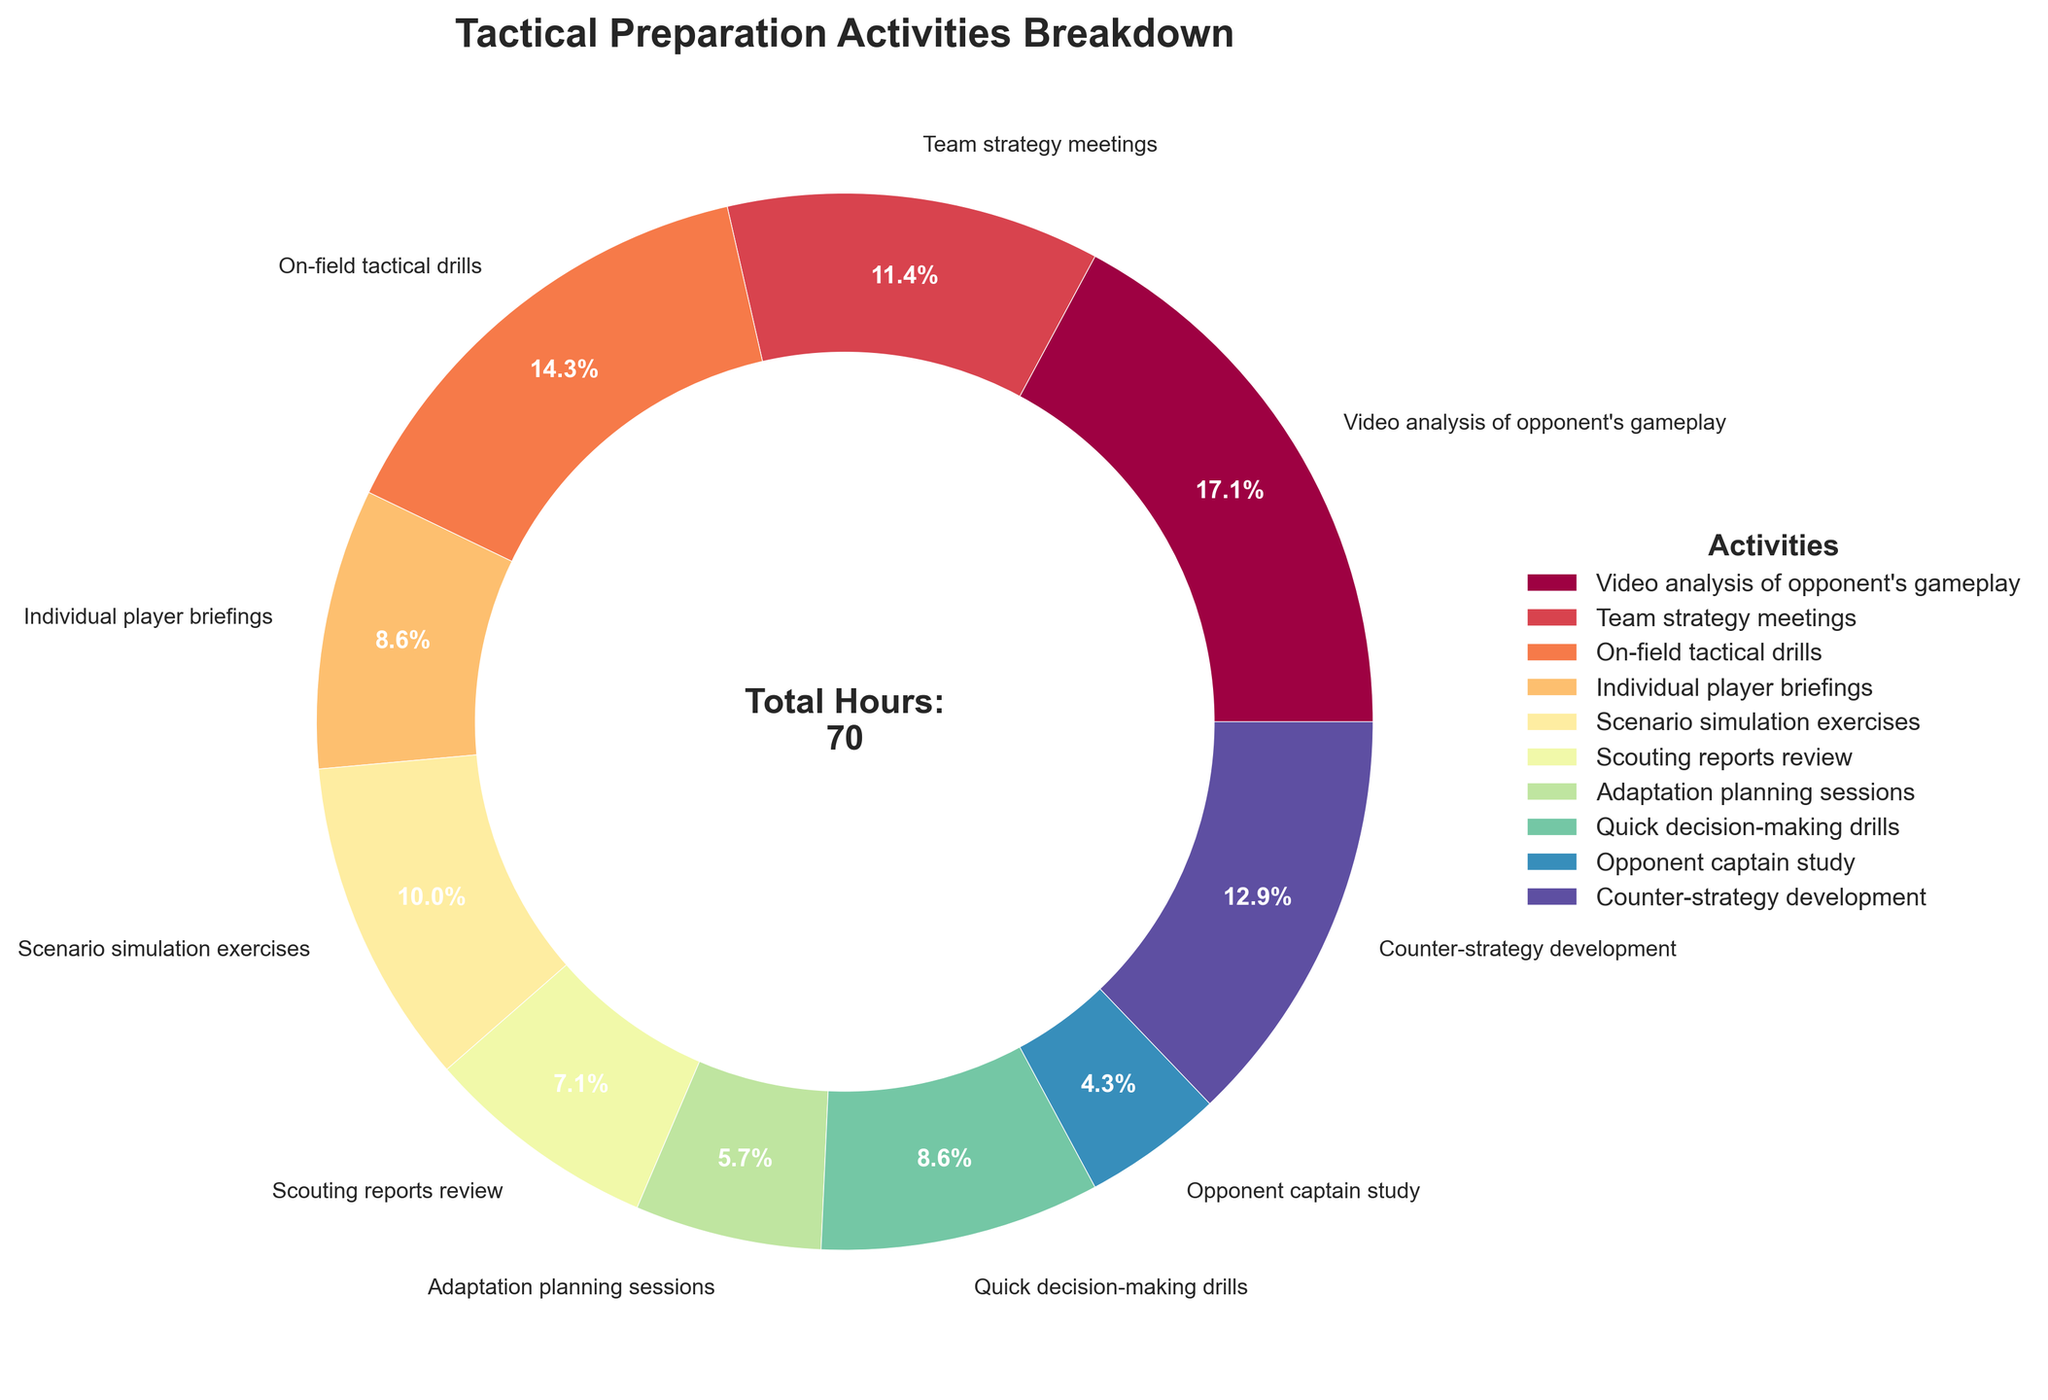What percentage of time is spent on Video analysis of opponent's gameplay? Video analysis of opponent's gameplay accounts for 12 hours. To find the percentage, divide 12 by the total hours and multiply by 100. Total hours = 70. (12 / 70) * 100 = 17.1%
Answer: 17.1% How many more hours are spent on On-field tactical drills compared to Opponent captain study? On-field tactical drills take 10 hours and Opponent captain study takes 3 hours. The difference is 10 - 3 = 7 hours
Answer: 7 hours Which activity takes up the second most amount of time? Counter-strategy development comes in second with 9 hours
Answer: Counter-strategy development How much time is spent on quick decision-making drills compared to Individual player briefings and Adaptation planning sessions combined? Quick decision-making drills: 6 hours. Individual player briefings: 6 hours. Adaptation planning sessions: 4 hours. Combined hours for the latter two = 6 + 4 = 10 hours. The comparison is 6 vs. 10 hours
Answer: 6 vs. 10 hours Which activity has the highest allocation of time and what is its percentage? The activity with the highest time allocation is Video analysis of opponent's gameplay with 12 hours. Percentage = (12 / 70) * 100 = 17.1%
Answer: Video analysis of opponent's gameplay, 17.1% What is the combined percentage of activities that take up less than 6 hours? Activities less than 6 hours: Scouting reports review (5 hours), Adaptation planning sessions (4 hours), and Opponent captain study (3 hours). Total hours = 5 + 4 + 3 = 12. Percentage = (12 / 70) * 100 = 17.1%
Answer: 17.1% Which activity occupies the smallest slice in the pie chart and what color is it? Opponent captain study is the smallest slice with 3 hours and it is represented in a color near the end of the color spectrum, likely a shade of purple.
Answer: Opponent captain study, purple What is the total number of hours allocated to Scenario simulation exercises and Counter-strategy development? Scenario simulation exercises: 7 hours. Counter-strategy development: 9 hours. Total = 7 + 9 = 16 hours
Answer: 16 hours What is the average time spent on activities that are allocated more than 7 hours each? Activities > 7 hours: Video analysis of opponent's gameplay (12), Team strategy meetings (8), On-field tactical drills (10), Scenario simulation exercises (7), Counter-strategy development (9). Total hours = 12 + 8 + 10 + 7 + 9 = 46. Number of activities = 5. Average = 46 / 5 = 9.2 hours
Answer: 9.2 hours 